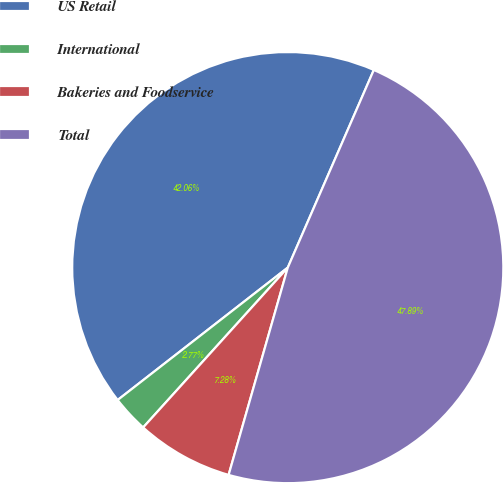Convert chart to OTSL. <chart><loc_0><loc_0><loc_500><loc_500><pie_chart><fcel>US Retail<fcel>International<fcel>Bakeries and Foodservice<fcel>Total<nl><fcel>42.06%<fcel>2.77%<fcel>7.28%<fcel>47.89%<nl></chart> 